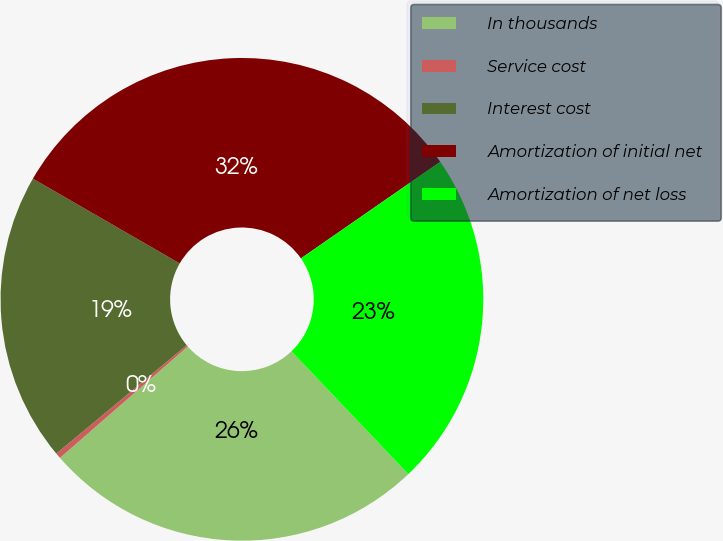Convert chart. <chart><loc_0><loc_0><loc_500><loc_500><pie_chart><fcel>In thousands<fcel>Service cost<fcel>Interest cost<fcel>Amortization of initial net<fcel>Amortization of net loss<nl><fcel>25.7%<fcel>0.37%<fcel>19.37%<fcel>32.02%<fcel>22.54%<nl></chart> 